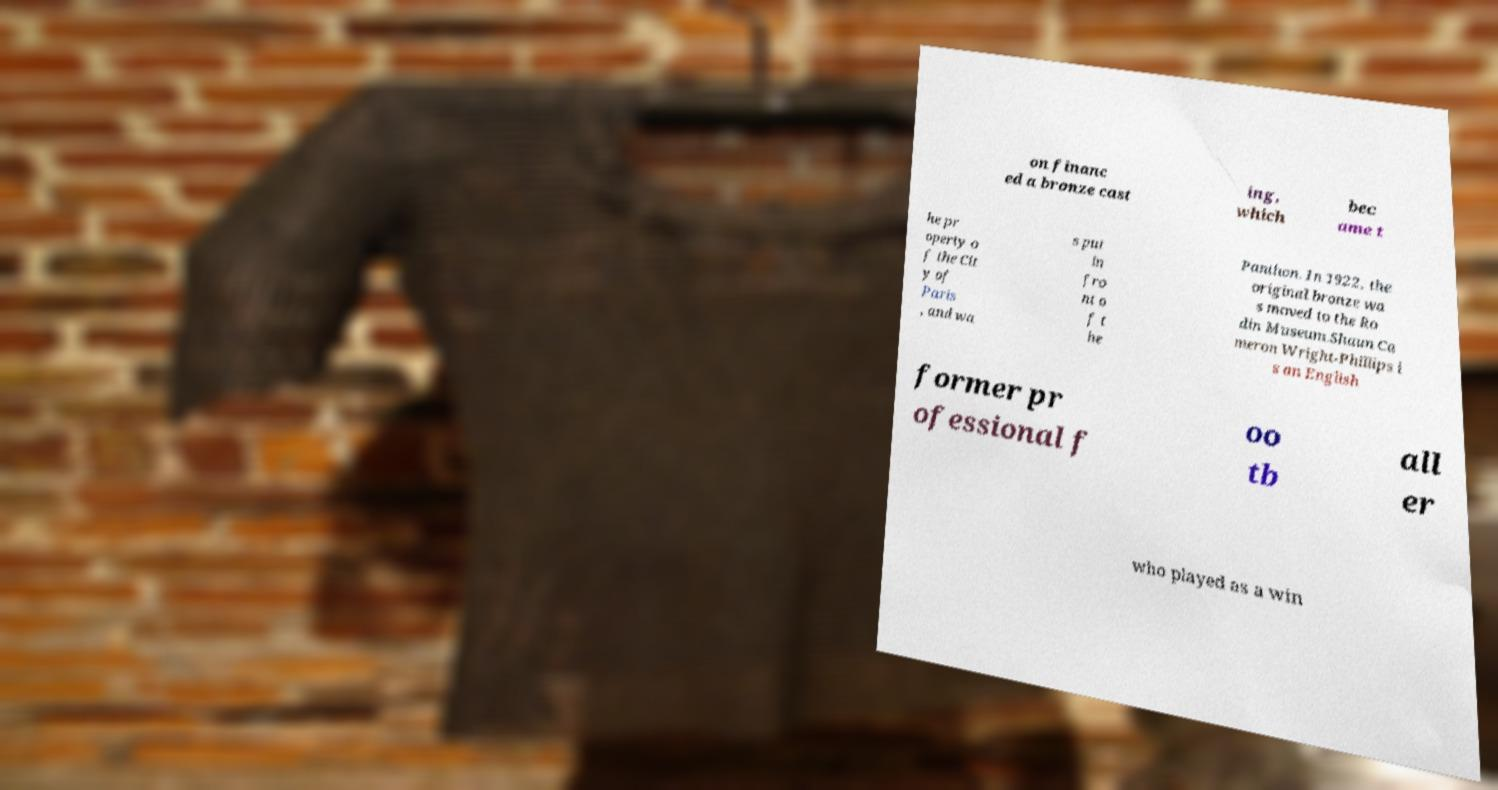What messages or text are displayed in this image? I need them in a readable, typed format. on financ ed a bronze cast ing, which bec ame t he pr operty o f the Cit y of Paris , and wa s put in fro nt o f t he Panthon. In 1922, the original bronze wa s moved to the Ro din Museum.Shaun Ca meron Wright-Phillips i s an English former pr ofessional f oo tb all er who played as a win 